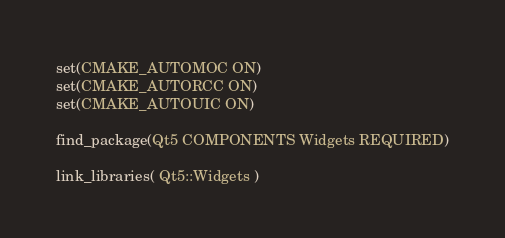<code> <loc_0><loc_0><loc_500><loc_500><_CMake_>
set(CMAKE_AUTOMOC ON)
set(CMAKE_AUTORCC ON)
set(CMAKE_AUTOUIC ON)

find_package(Qt5 COMPONENTS Widgets REQUIRED)

link_libraries( Qt5::Widgets )

</code> 